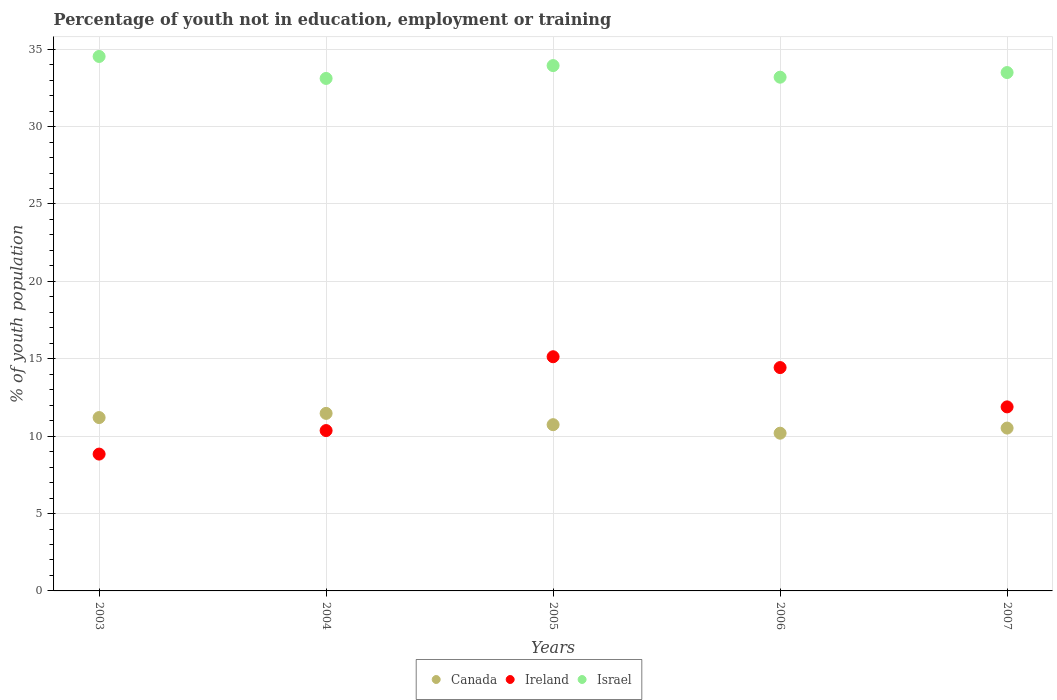Is the number of dotlines equal to the number of legend labels?
Offer a very short reply. Yes. What is the percentage of unemployed youth population in in Ireland in 2007?
Offer a very short reply. 11.89. Across all years, what is the maximum percentage of unemployed youth population in in Ireland?
Your answer should be very brief. 15.13. Across all years, what is the minimum percentage of unemployed youth population in in Canada?
Provide a succinct answer. 10.19. In which year was the percentage of unemployed youth population in in Canada maximum?
Your answer should be compact. 2004. In which year was the percentage of unemployed youth population in in Ireland minimum?
Offer a very short reply. 2003. What is the total percentage of unemployed youth population in in Ireland in the graph?
Your response must be concise. 60.65. What is the difference between the percentage of unemployed youth population in in Israel in 2005 and that in 2007?
Ensure brevity in your answer.  0.45. What is the difference between the percentage of unemployed youth population in in Ireland in 2006 and the percentage of unemployed youth population in in Canada in 2004?
Offer a terse response. 2.96. What is the average percentage of unemployed youth population in in Ireland per year?
Offer a very short reply. 12.13. In the year 2006, what is the difference between the percentage of unemployed youth population in in Ireland and percentage of unemployed youth population in in Canada?
Ensure brevity in your answer.  4.24. In how many years, is the percentage of unemployed youth population in in Canada greater than 4 %?
Offer a terse response. 5. What is the ratio of the percentage of unemployed youth population in in Canada in 2004 to that in 2006?
Your response must be concise. 1.13. What is the difference between the highest and the second highest percentage of unemployed youth population in in Ireland?
Ensure brevity in your answer.  0.7. What is the difference between the highest and the lowest percentage of unemployed youth population in in Canada?
Provide a short and direct response. 1.28. In how many years, is the percentage of unemployed youth population in in Israel greater than the average percentage of unemployed youth population in in Israel taken over all years?
Ensure brevity in your answer.  2. Is the sum of the percentage of unemployed youth population in in Canada in 2003 and 2004 greater than the maximum percentage of unemployed youth population in in Ireland across all years?
Your answer should be very brief. Yes. Is it the case that in every year, the sum of the percentage of unemployed youth population in in Canada and percentage of unemployed youth population in in Israel  is greater than the percentage of unemployed youth population in in Ireland?
Offer a terse response. Yes. Does the percentage of unemployed youth population in in Ireland monotonically increase over the years?
Ensure brevity in your answer.  No. Is the percentage of unemployed youth population in in Canada strictly greater than the percentage of unemployed youth population in in Israel over the years?
Offer a terse response. No. Does the graph contain any zero values?
Make the answer very short. No. Does the graph contain grids?
Offer a terse response. Yes. How are the legend labels stacked?
Keep it short and to the point. Horizontal. What is the title of the graph?
Provide a short and direct response. Percentage of youth not in education, employment or training. Does "Germany" appear as one of the legend labels in the graph?
Keep it short and to the point. No. What is the label or title of the X-axis?
Offer a terse response. Years. What is the label or title of the Y-axis?
Offer a very short reply. % of youth population. What is the % of youth population in Canada in 2003?
Offer a terse response. 11.2. What is the % of youth population in Ireland in 2003?
Keep it short and to the point. 8.84. What is the % of youth population of Israel in 2003?
Make the answer very short. 34.53. What is the % of youth population of Canada in 2004?
Ensure brevity in your answer.  11.47. What is the % of youth population in Ireland in 2004?
Ensure brevity in your answer.  10.36. What is the % of youth population of Israel in 2004?
Your answer should be very brief. 33.11. What is the % of youth population in Canada in 2005?
Provide a short and direct response. 10.74. What is the % of youth population in Ireland in 2005?
Give a very brief answer. 15.13. What is the % of youth population in Israel in 2005?
Your response must be concise. 33.94. What is the % of youth population of Canada in 2006?
Make the answer very short. 10.19. What is the % of youth population in Ireland in 2006?
Offer a terse response. 14.43. What is the % of youth population of Israel in 2006?
Provide a short and direct response. 33.19. What is the % of youth population in Canada in 2007?
Provide a succinct answer. 10.52. What is the % of youth population of Ireland in 2007?
Offer a terse response. 11.89. What is the % of youth population of Israel in 2007?
Make the answer very short. 33.49. Across all years, what is the maximum % of youth population of Canada?
Your response must be concise. 11.47. Across all years, what is the maximum % of youth population of Ireland?
Make the answer very short. 15.13. Across all years, what is the maximum % of youth population in Israel?
Your answer should be compact. 34.53. Across all years, what is the minimum % of youth population in Canada?
Provide a succinct answer. 10.19. Across all years, what is the minimum % of youth population of Ireland?
Provide a short and direct response. 8.84. Across all years, what is the minimum % of youth population of Israel?
Your answer should be compact. 33.11. What is the total % of youth population of Canada in the graph?
Ensure brevity in your answer.  54.12. What is the total % of youth population in Ireland in the graph?
Offer a terse response. 60.65. What is the total % of youth population in Israel in the graph?
Provide a succinct answer. 168.26. What is the difference between the % of youth population in Canada in 2003 and that in 2004?
Ensure brevity in your answer.  -0.27. What is the difference between the % of youth population of Ireland in 2003 and that in 2004?
Your answer should be compact. -1.52. What is the difference between the % of youth population of Israel in 2003 and that in 2004?
Your answer should be compact. 1.42. What is the difference between the % of youth population in Canada in 2003 and that in 2005?
Ensure brevity in your answer.  0.46. What is the difference between the % of youth population in Ireland in 2003 and that in 2005?
Give a very brief answer. -6.29. What is the difference between the % of youth population of Israel in 2003 and that in 2005?
Offer a very short reply. 0.59. What is the difference between the % of youth population in Ireland in 2003 and that in 2006?
Provide a short and direct response. -5.59. What is the difference between the % of youth population in Israel in 2003 and that in 2006?
Offer a terse response. 1.34. What is the difference between the % of youth population in Canada in 2003 and that in 2007?
Provide a succinct answer. 0.68. What is the difference between the % of youth population in Ireland in 2003 and that in 2007?
Your response must be concise. -3.05. What is the difference between the % of youth population of Canada in 2004 and that in 2005?
Your answer should be compact. 0.73. What is the difference between the % of youth population in Ireland in 2004 and that in 2005?
Your answer should be compact. -4.77. What is the difference between the % of youth population in Israel in 2004 and that in 2005?
Make the answer very short. -0.83. What is the difference between the % of youth population in Canada in 2004 and that in 2006?
Make the answer very short. 1.28. What is the difference between the % of youth population of Ireland in 2004 and that in 2006?
Your answer should be very brief. -4.07. What is the difference between the % of youth population in Israel in 2004 and that in 2006?
Keep it short and to the point. -0.08. What is the difference between the % of youth population in Ireland in 2004 and that in 2007?
Keep it short and to the point. -1.53. What is the difference between the % of youth population in Israel in 2004 and that in 2007?
Your answer should be compact. -0.38. What is the difference between the % of youth population in Canada in 2005 and that in 2006?
Your answer should be very brief. 0.55. What is the difference between the % of youth population in Ireland in 2005 and that in 2006?
Offer a very short reply. 0.7. What is the difference between the % of youth population in Israel in 2005 and that in 2006?
Keep it short and to the point. 0.75. What is the difference between the % of youth population of Canada in 2005 and that in 2007?
Offer a terse response. 0.22. What is the difference between the % of youth population of Ireland in 2005 and that in 2007?
Provide a short and direct response. 3.24. What is the difference between the % of youth population in Israel in 2005 and that in 2007?
Offer a very short reply. 0.45. What is the difference between the % of youth population in Canada in 2006 and that in 2007?
Provide a succinct answer. -0.33. What is the difference between the % of youth population of Ireland in 2006 and that in 2007?
Provide a succinct answer. 2.54. What is the difference between the % of youth population of Israel in 2006 and that in 2007?
Your answer should be very brief. -0.3. What is the difference between the % of youth population of Canada in 2003 and the % of youth population of Ireland in 2004?
Provide a short and direct response. 0.84. What is the difference between the % of youth population in Canada in 2003 and the % of youth population in Israel in 2004?
Provide a succinct answer. -21.91. What is the difference between the % of youth population of Ireland in 2003 and the % of youth population of Israel in 2004?
Give a very brief answer. -24.27. What is the difference between the % of youth population of Canada in 2003 and the % of youth population of Ireland in 2005?
Keep it short and to the point. -3.93. What is the difference between the % of youth population in Canada in 2003 and the % of youth population in Israel in 2005?
Your answer should be compact. -22.74. What is the difference between the % of youth population of Ireland in 2003 and the % of youth population of Israel in 2005?
Provide a succinct answer. -25.1. What is the difference between the % of youth population of Canada in 2003 and the % of youth population of Ireland in 2006?
Ensure brevity in your answer.  -3.23. What is the difference between the % of youth population in Canada in 2003 and the % of youth population in Israel in 2006?
Your answer should be very brief. -21.99. What is the difference between the % of youth population of Ireland in 2003 and the % of youth population of Israel in 2006?
Your answer should be compact. -24.35. What is the difference between the % of youth population of Canada in 2003 and the % of youth population of Ireland in 2007?
Keep it short and to the point. -0.69. What is the difference between the % of youth population in Canada in 2003 and the % of youth population in Israel in 2007?
Give a very brief answer. -22.29. What is the difference between the % of youth population of Ireland in 2003 and the % of youth population of Israel in 2007?
Keep it short and to the point. -24.65. What is the difference between the % of youth population in Canada in 2004 and the % of youth population in Ireland in 2005?
Make the answer very short. -3.66. What is the difference between the % of youth population of Canada in 2004 and the % of youth population of Israel in 2005?
Give a very brief answer. -22.47. What is the difference between the % of youth population in Ireland in 2004 and the % of youth population in Israel in 2005?
Your answer should be compact. -23.58. What is the difference between the % of youth population of Canada in 2004 and the % of youth population of Ireland in 2006?
Make the answer very short. -2.96. What is the difference between the % of youth population in Canada in 2004 and the % of youth population in Israel in 2006?
Provide a succinct answer. -21.72. What is the difference between the % of youth population in Ireland in 2004 and the % of youth population in Israel in 2006?
Give a very brief answer. -22.83. What is the difference between the % of youth population in Canada in 2004 and the % of youth population in Ireland in 2007?
Your answer should be compact. -0.42. What is the difference between the % of youth population in Canada in 2004 and the % of youth population in Israel in 2007?
Give a very brief answer. -22.02. What is the difference between the % of youth population of Ireland in 2004 and the % of youth population of Israel in 2007?
Your response must be concise. -23.13. What is the difference between the % of youth population in Canada in 2005 and the % of youth population in Ireland in 2006?
Offer a very short reply. -3.69. What is the difference between the % of youth population of Canada in 2005 and the % of youth population of Israel in 2006?
Your response must be concise. -22.45. What is the difference between the % of youth population in Ireland in 2005 and the % of youth population in Israel in 2006?
Keep it short and to the point. -18.06. What is the difference between the % of youth population in Canada in 2005 and the % of youth population in Ireland in 2007?
Make the answer very short. -1.15. What is the difference between the % of youth population of Canada in 2005 and the % of youth population of Israel in 2007?
Offer a terse response. -22.75. What is the difference between the % of youth population of Ireland in 2005 and the % of youth population of Israel in 2007?
Provide a short and direct response. -18.36. What is the difference between the % of youth population in Canada in 2006 and the % of youth population in Israel in 2007?
Keep it short and to the point. -23.3. What is the difference between the % of youth population of Ireland in 2006 and the % of youth population of Israel in 2007?
Your answer should be very brief. -19.06. What is the average % of youth population of Canada per year?
Offer a very short reply. 10.82. What is the average % of youth population of Ireland per year?
Give a very brief answer. 12.13. What is the average % of youth population in Israel per year?
Make the answer very short. 33.65. In the year 2003, what is the difference between the % of youth population in Canada and % of youth population in Ireland?
Your answer should be compact. 2.36. In the year 2003, what is the difference between the % of youth population of Canada and % of youth population of Israel?
Provide a succinct answer. -23.33. In the year 2003, what is the difference between the % of youth population in Ireland and % of youth population in Israel?
Your response must be concise. -25.69. In the year 2004, what is the difference between the % of youth population of Canada and % of youth population of Ireland?
Provide a succinct answer. 1.11. In the year 2004, what is the difference between the % of youth population of Canada and % of youth population of Israel?
Provide a short and direct response. -21.64. In the year 2004, what is the difference between the % of youth population in Ireland and % of youth population in Israel?
Your response must be concise. -22.75. In the year 2005, what is the difference between the % of youth population in Canada and % of youth population in Ireland?
Make the answer very short. -4.39. In the year 2005, what is the difference between the % of youth population of Canada and % of youth population of Israel?
Offer a terse response. -23.2. In the year 2005, what is the difference between the % of youth population of Ireland and % of youth population of Israel?
Ensure brevity in your answer.  -18.81. In the year 2006, what is the difference between the % of youth population in Canada and % of youth population in Ireland?
Provide a short and direct response. -4.24. In the year 2006, what is the difference between the % of youth population in Canada and % of youth population in Israel?
Keep it short and to the point. -23. In the year 2006, what is the difference between the % of youth population in Ireland and % of youth population in Israel?
Your response must be concise. -18.76. In the year 2007, what is the difference between the % of youth population in Canada and % of youth population in Ireland?
Offer a very short reply. -1.37. In the year 2007, what is the difference between the % of youth population of Canada and % of youth population of Israel?
Offer a terse response. -22.97. In the year 2007, what is the difference between the % of youth population of Ireland and % of youth population of Israel?
Your answer should be very brief. -21.6. What is the ratio of the % of youth population of Canada in 2003 to that in 2004?
Keep it short and to the point. 0.98. What is the ratio of the % of youth population of Ireland in 2003 to that in 2004?
Ensure brevity in your answer.  0.85. What is the ratio of the % of youth population of Israel in 2003 to that in 2004?
Keep it short and to the point. 1.04. What is the ratio of the % of youth population in Canada in 2003 to that in 2005?
Give a very brief answer. 1.04. What is the ratio of the % of youth population in Ireland in 2003 to that in 2005?
Make the answer very short. 0.58. What is the ratio of the % of youth population of Israel in 2003 to that in 2005?
Provide a short and direct response. 1.02. What is the ratio of the % of youth population in Canada in 2003 to that in 2006?
Give a very brief answer. 1.1. What is the ratio of the % of youth population in Ireland in 2003 to that in 2006?
Make the answer very short. 0.61. What is the ratio of the % of youth population of Israel in 2003 to that in 2006?
Your response must be concise. 1.04. What is the ratio of the % of youth population in Canada in 2003 to that in 2007?
Provide a short and direct response. 1.06. What is the ratio of the % of youth population of Ireland in 2003 to that in 2007?
Your answer should be very brief. 0.74. What is the ratio of the % of youth population in Israel in 2003 to that in 2007?
Your response must be concise. 1.03. What is the ratio of the % of youth population of Canada in 2004 to that in 2005?
Your response must be concise. 1.07. What is the ratio of the % of youth population in Ireland in 2004 to that in 2005?
Your answer should be very brief. 0.68. What is the ratio of the % of youth population of Israel in 2004 to that in 2005?
Provide a short and direct response. 0.98. What is the ratio of the % of youth population in Canada in 2004 to that in 2006?
Offer a terse response. 1.13. What is the ratio of the % of youth population of Ireland in 2004 to that in 2006?
Your answer should be compact. 0.72. What is the ratio of the % of youth population in Canada in 2004 to that in 2007?
Offer a terse response. 1.09. What is the ratio of the % of youth population in Ireland in 2004 to that in 2007?
Your answer should be very brief. 0.87. What is the ratio of the % of youth population in Israel in 2004 to that in 2007?
Your answer should be very brief. 0.99. What is the ratio of the % of youth population of Canada in 2005 to that in 2006?
Your answer should be compact. 1.05. What is the ratio of the % of youth population in Ireland in 2005 to that in 2006?
Offer a very short reply. 1.05. What is the ratio of the % of youth population of Israel in 2005 to that in 2006?
Provide a short and direct response. 1.02. What is the ratio of the % of youth population of Canada in 2005 to that in 2007?
Ensure brevity in your answer.  1.02. What is the ratio of the % of youth population of Ireland in 2005 to that in 2007?
Your response must be concise. 1.27. What is the ratio of the % of youth population of Israel in 2005 to that in 2007?
Offer a very short reply. 1.01. What is the ratio of the % of youth population in Canada in 2006 to that in 2007?
Your response must be concise. 0.97. What is the ratio of the % of youth population in Ireland in 2006 to that in 2007?
Ensure brevity in your answer.  1.21. What is the difference between the highest and the second highest % of youth population of Canada?
Ensure brevity in your answer.  0.27. What is the difference between the highest and the second highest % of youth population in Ireland?
Offer a very short reply. 0.7. What is the difference between the highest and the second highest % of youth population in Israel?
Make the answer very short. 0.59. What is the difference between the highest and the lowest % of youth population in Canada?
Your response must be concise. 1.28. What is the difference between the highest and the lowest % of youth population in Ireland?
Your answer should be very brief. 6.29. What is the difference between the highest and the lowest % of youth population in Israel?
Offer a very short reply. 1.42. 